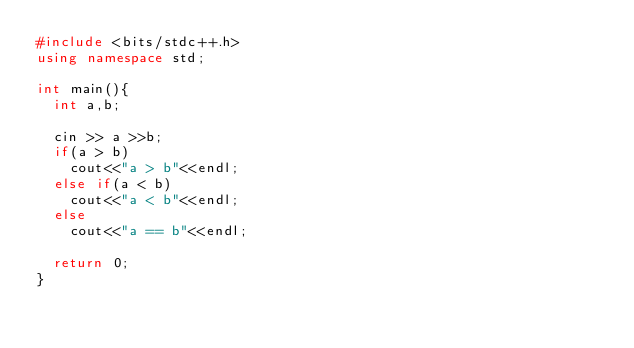<code> <loc_0><loc_0><loc_500><loc_500><_C++_>#include <bits/stdc++.h>
using namespace std;

int main(){
	int a,b;

	cin >> a >>b;
	if(a > b)
		cout<<"a > b"<<endl;
	else if(a < b)
		cout<<"a < b"<<endl;
 	else
		cout<<"a == b"<<endl;

	return 0;
}</code> 